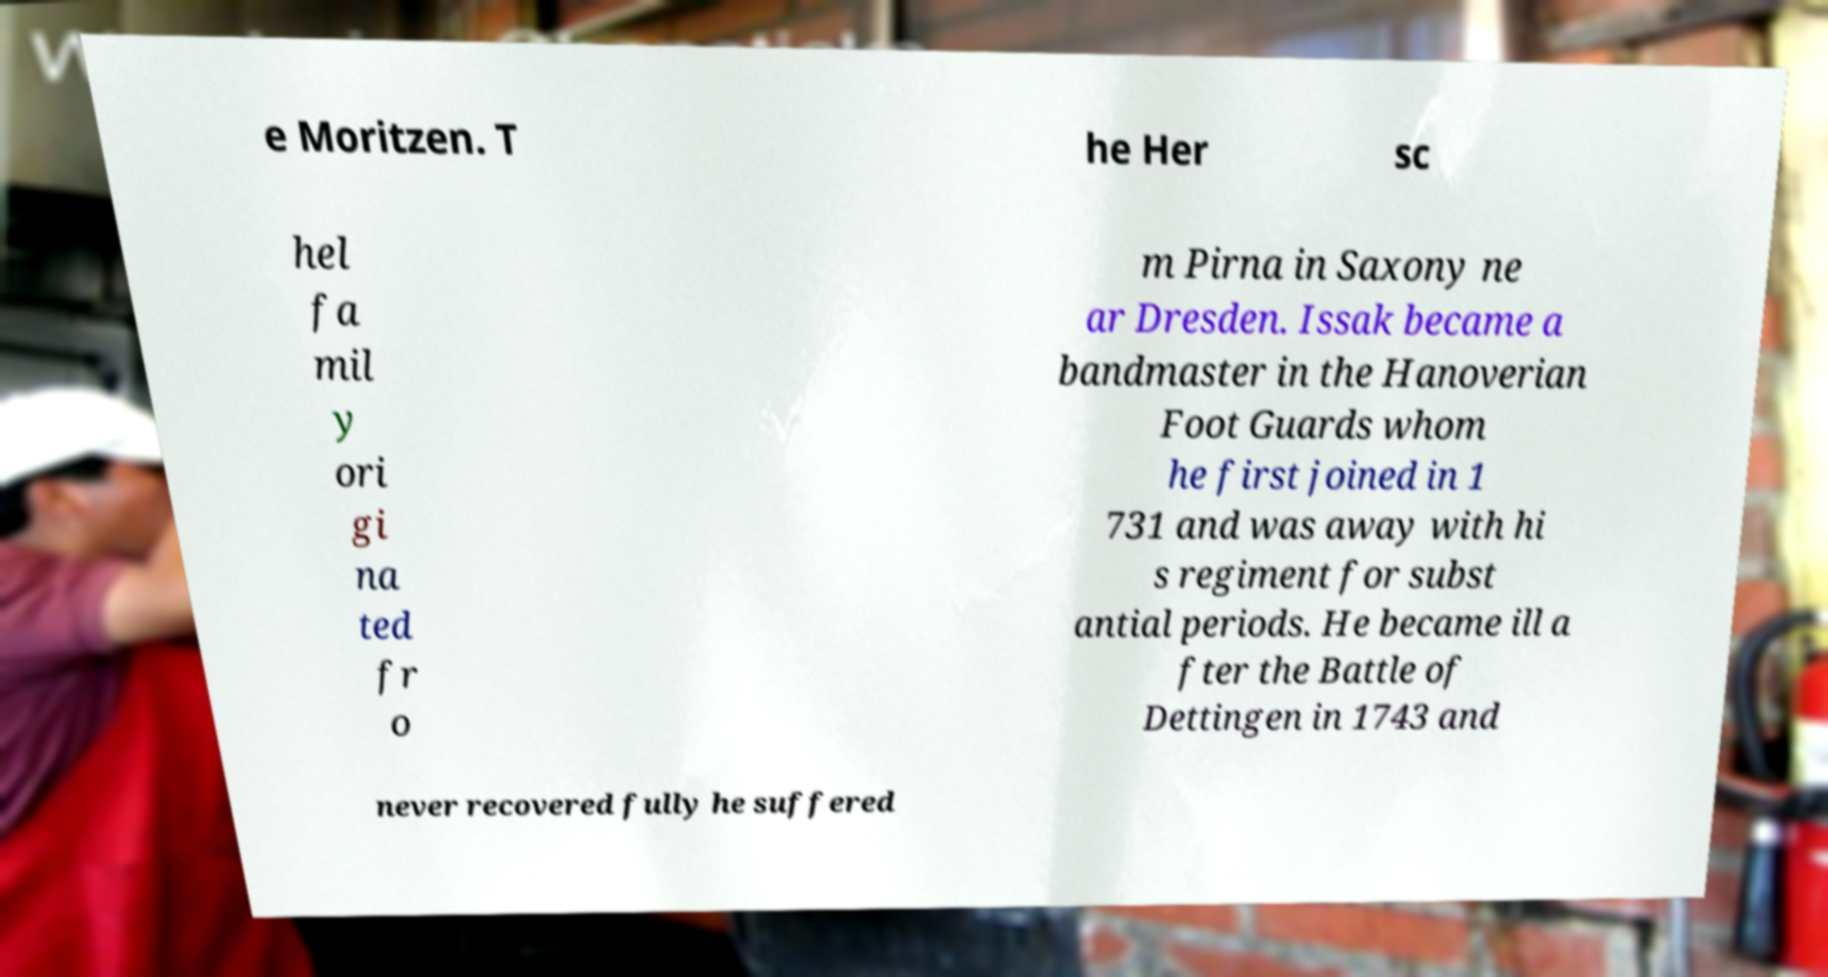What messages or text are displayed in this image? I need them in a readable, typed format. e Moritzen. T he Her sc hel fa mil y ori gi na ted fr o m Pirna in Saxony ne ar Dresden. Issak became a bandmaster in the Hanoverian Foot Guards whom he first joined in 1 731 and was away with hi s regiment for subst antial periods. He became ill a fter the Battle of Dettingen in 1743 and never recovered fully he suffered 